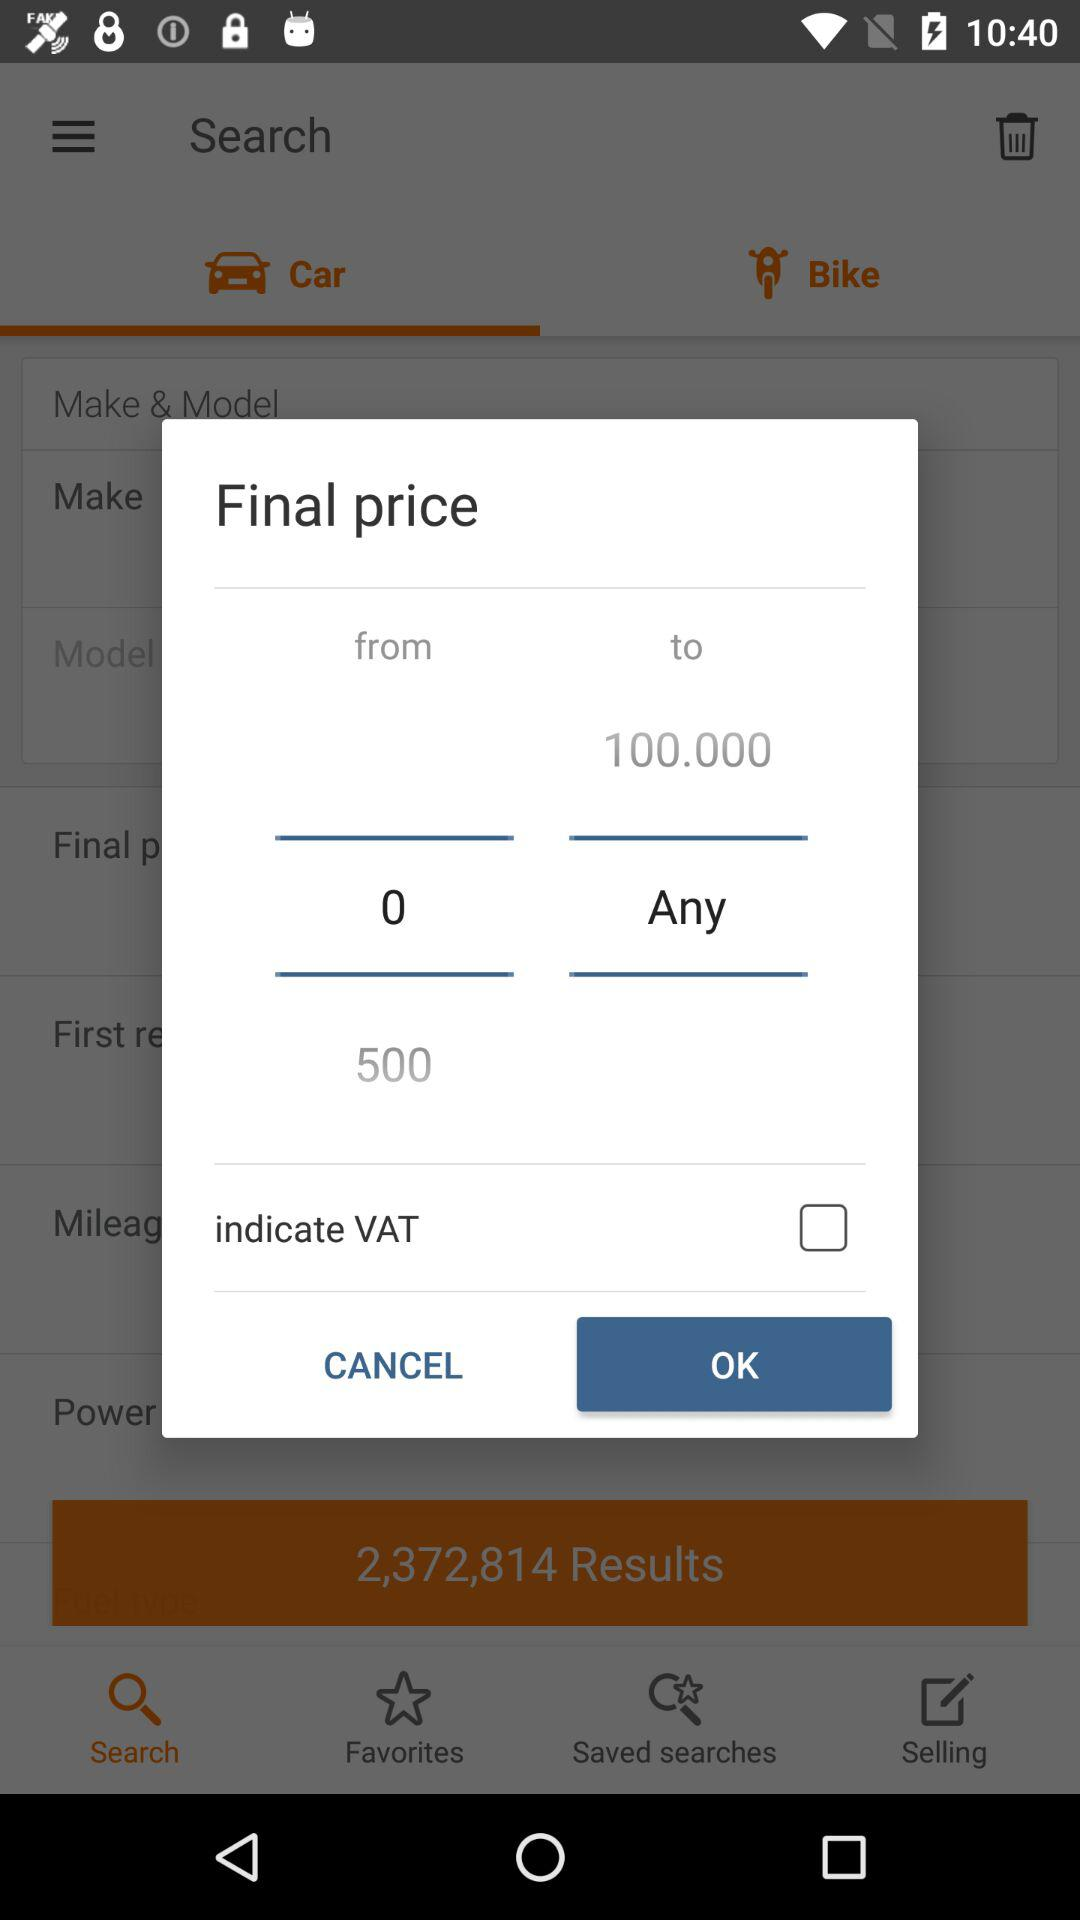What is the minimum amount of money that can be entered?
Answer the question using a single word or phrase. 0 